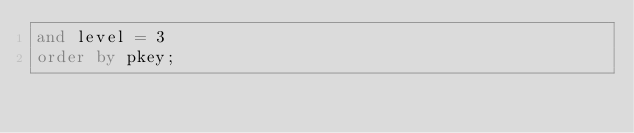<code> <loc_0><loc_0><loc_500><loc_500><_SQL_>and level = 3
order by pkey;</code> 